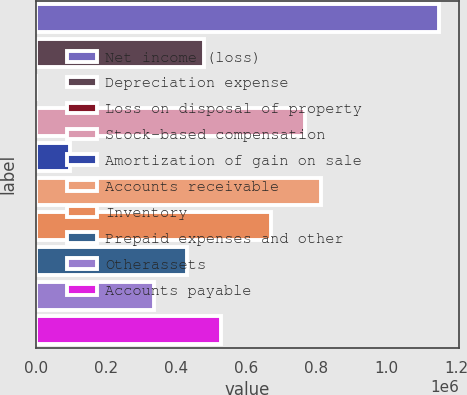Convert chart. <chart><loc_0><loc_0><loc_500><loc_500><bar_chart><fcel>Net income (loss)<fcel>Depreciation expense<fcel>Loss on disposal of property<fcel>Stock-based compensation<fcel>Amortization of gain on sale<fcel>Accounts receivable<fcel>Inventory<fcel>Prepaid expenses and other<fcel>Otherassets<fcel>Accounts payable<nl><fcel>1.15058e+06<fcel>479415<fcel>15<fcel>767055<fcel>95895<fcel>814995<fcel>671175<fcel>431475<fcel>335595<fcel>527355<nl></chart> 